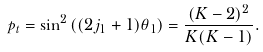Convert formula to latex. <formula><loc_0><loc_0><loc_500><loc_500>p _ { t } = \sin ^ { 2 } \left ( ( 2 j _ { 1 } + 1 ) \theta _ { 1 } \right ) = \frac { ( K - 2 ) ^ { 2 } } { K ( K - 1 ) } .</formula> 